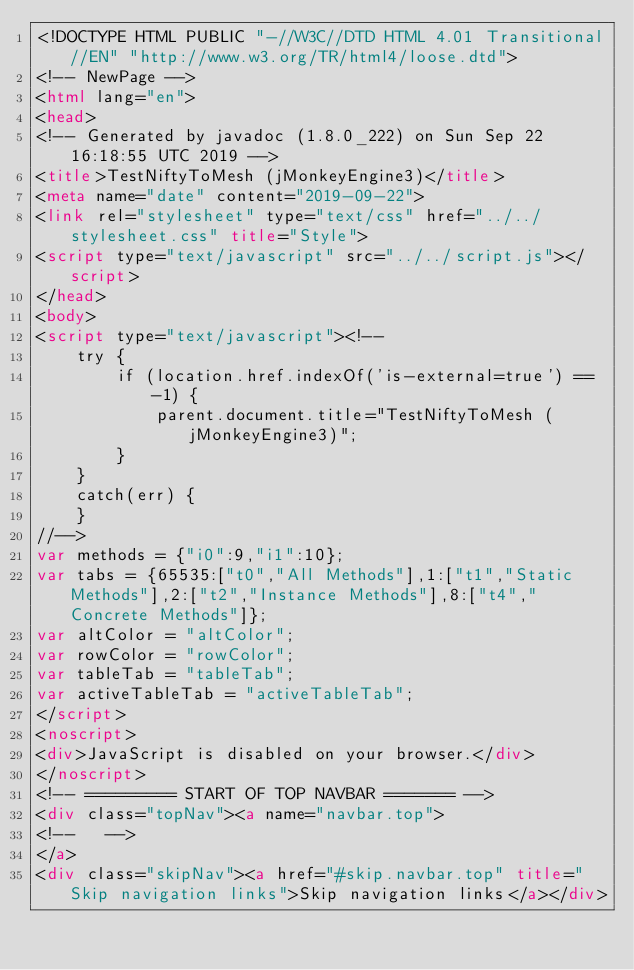Convert code to text. <code><loc_0><loc_0><loc_500><loc_500><_HTML_><!DOCTYPE HTML PUBLIC "-//W3C//DTD HTML 4.01 Transitional//EN" "http://www.w3.org/TR/html4/loose.dtd">
<!-- NewPage -->
<html lang="en">
<head>
<!-- Generated by javadoc (1.8.0_222) on Sun Sep 22 16:18:55 UTC 2019 -->
<title>TestNiftyToMesh (jMonkeyEngine3)</title>
<meta name="date" content="2019-09-22">
<link rel="stylesheet" type="text/css" href="../../stylesheet.css" title="Style">
<script type="text/javascript" src="../../script.js"></script>
</head>
<body>
<script type="text/javascript"><!--
    try {
        if (location.href.indexOf('is-external=true') == -1) {
            parent.document.title="TestNiftyToMesh (jMonkeyEngine3)";
        }
    }
    catch(err) {
    }
//-->
var methods = {"i0":9,"i1":10};
var tabs = {65535:["t0","All Methods"],1:["t1","Static Methods"],2:["t2","Instance Methods"],8:["t4","Concrete Methods"]};
var altColor = "altColor";
var rowColor = "rowColor";
var tableTab = "tableTab";
var activeTableTab = "activeTableTab";
</script>
<noscript>
<div>JavaScript is disabled on your browser.</div>
</noscript>
<!-- ========= START OF TOP NAVBAR ======= -->
<div class="topNav"><a name="navbar.top">
<!--   -->
</a>
<div class="skipNav"><a href="#skip.navbar.top" title="Skip navigation links">Skip navigation links</a></div></code> 